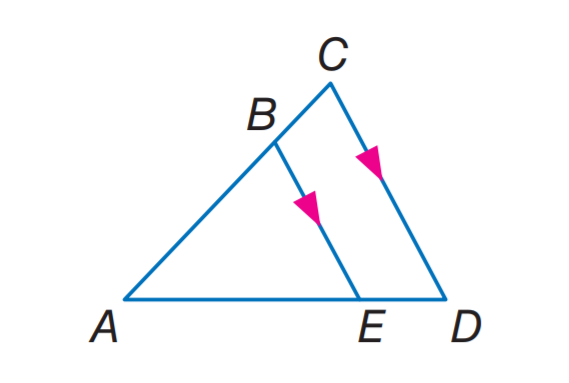Question: If A B = 6, B C = 4, and A E = 9, find E D.
Choices:
A. 4
B. 6
C. 9
D. 12
Answer with the letter. Answer: B Question: If A C = 14, B C = 8, and A D = 21, find E D.
Choices:
A. 8
B. 12
C. 14
D. 21
Answer with the letter. Answer: B Question: If A D = 27, A B = 8, and A E = 12, find B C.
Choices:
A. 8
B. 10
C. 12
D. 13.5
Answer with the letter. Answer: B 